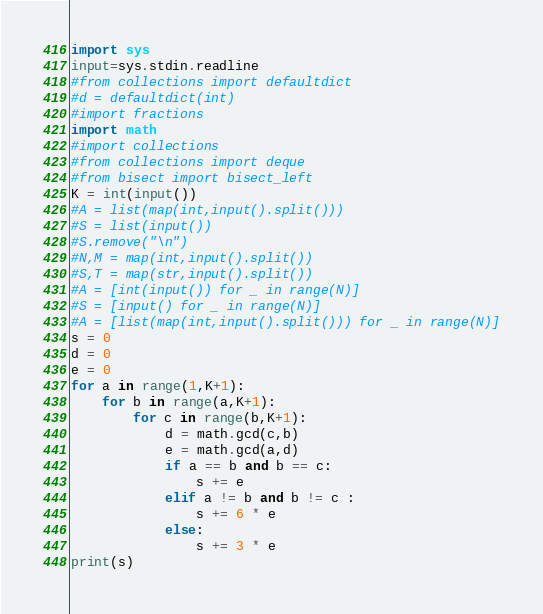Convert code to text. <code><loc_0><loc_0><loc_500><loc_500><_Python_>import sys
input=sys.stdin.readline
#from collections import defaultdict
#d = defaultdict(int)
#import fractions
import math
#import collections
#from collections import deque
#from bisect import bisect_left
K = int(input())
#A = list(map(int,input().split()))
#S = list(input())
#S.remove("\n")
#N,M = map(int,input().split())
#S,T = map(str,input().split())
#A = [int(input()) for _ in range(N)]
#S = [input() for _ in range(N)]
#A = [list(map(int,input().split())) for _ in range(N)]
s = 0
d = 0
e = 0
for a in range(1,K+1):
    for b in range(a,K+1):
        for c in range(b,K+1):
            d = math.gcd(c,b)
            e = math.gcd(a,d)
            if a == b and b == c:
                s += e
            elif a != b and b != c :
                s += 6 * e
            else:
                s += 3 * e
print(s)</code> 